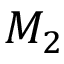Convert formula to latex. <formula><loc_0><loc_0><loc_500><loc_500>M _ { 2 }</formula> 